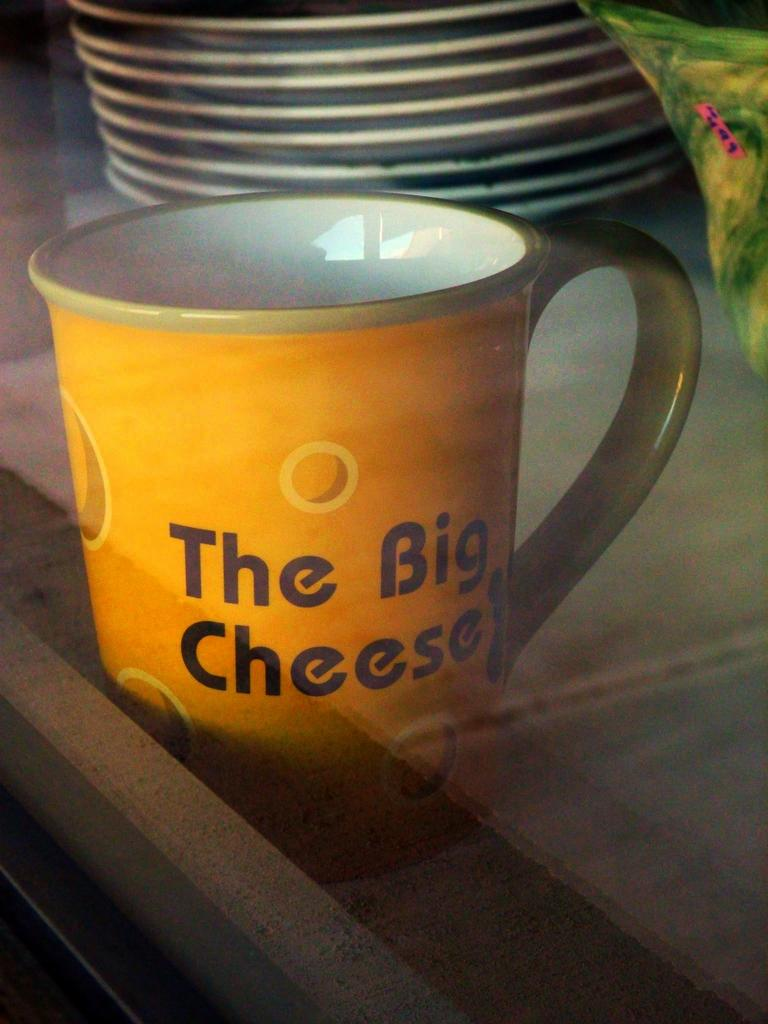What is the main object in the center of the image? There is a mug in the center of the image. What can be seen on the mug? The mug has text on it. On what surface is the mug placed? The mug is placed on an object, likely a table. What can be seen in the background of the image? There are plates visible in the background of the image, as well as other objects. What type of kite is being used as a cushion for the potato in the image? There is no kite, cushion, or potato present in the image. 